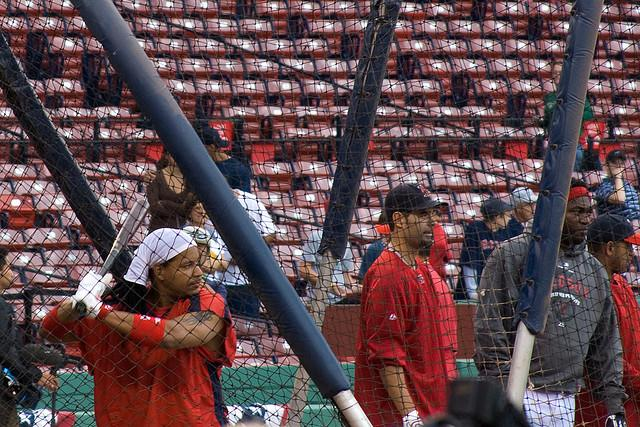Which base ball sport equipment is made up with maple wood? Please explain your reasoning. bat. The man is using a stick to hot the ball. 